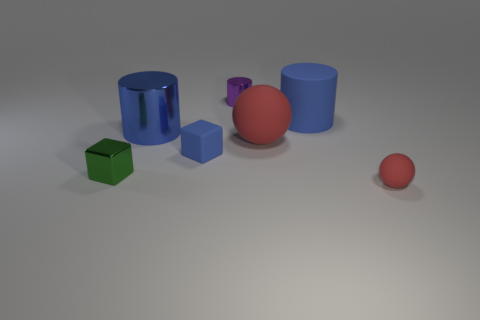Add 2 spheres. How many objects exist? 9 Subtract all cylinders. How many objects are left? 4 Subtract 0 red cylinders. How many objects are left? 7 Subtract all big things. Subtract all tiny gray things. How many objects are left? 4 Add 6 small matte blocks. How many small matte blocks are left? 7 Add 6 large yellow metal cylinders. How many large yellow metal cylinders exist? 6 